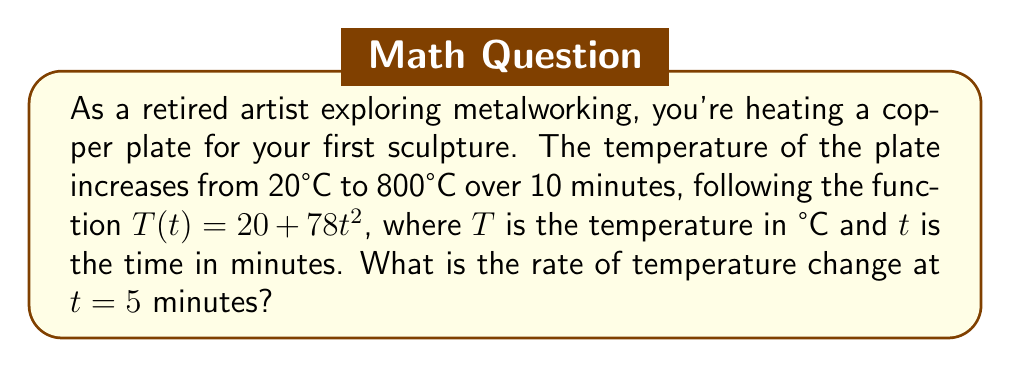Show me your answer to this math problem. To find the rate of temperature change, we need to calculate the derivative of the temperature function with respect to time.

1. Given temperature function: $T(t) = 20 + 78t^2$

2. Calculate the derivative:
   $$\frac{dT}{dt} = \frac{d}{dt}(20 + 78t^2) = 0 + 78 \cdot 2t = 156t$$

3. The rate of temperature change at any time $t$ is given by $\frac{dT}{dt} = 156t$ °C/min

4. At $t = 5$ minutes:
   $$\frac{dT}{dt}\bigg|_{t=5} = 156 \cdot 5 = 780$$

Therefore, the rate of temperature change at $t = 5$ minutes is 780 °C/min.
Answer: 780 °C/min 